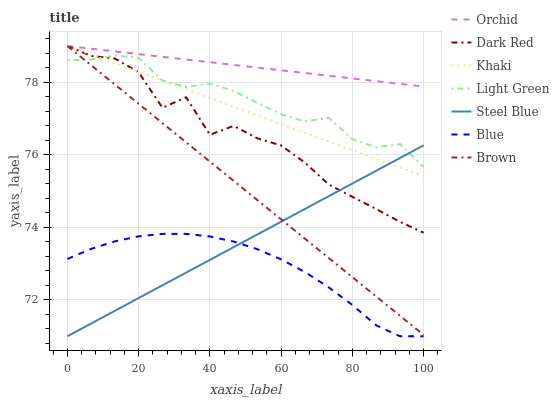Does Blue have the minimum area under the curve?
Answer yes or no. Yes. Does Orchid have the maximum area under the curve?
Answer yes or no. Yes. Does Brown have the minimum area under the curve?
Answer yes or no. No. Does Brown have the maximum area under the curve?
Answer yes or no. No. Is Brown the smoothest?
Answer yes or no. Yes. Is Dark Red the roughest?
Answer yes or no. Yes. Is Khaki the smoothest?
Answer yes or no. No. Is Khaki the roughest?
Answer yes or no. No. Does Blue have the lowest value?
Answer yes or no. Yes. Does Brown have the lowest value?
Answer yes or no. No. Does Orchid have the highest value?
Answer yes or no. Yes. Does Steel Blue have the highest value?
Answer yes or no. No. Is Steel Blue less than Orchid?
Answer yes or no. Yes. Is Orchid greater than Blue?
Answer yes or no. Yes. Does Dark Red intersect Brown?
Answer yes or no. Yes. Is Dark Red less than Brown?
Answer yes or no. No. Is Dark Red greater than Brown?
Answer yes or no. No. Does Steel Blue intersect Orchid?
Answer yes or no. No. 